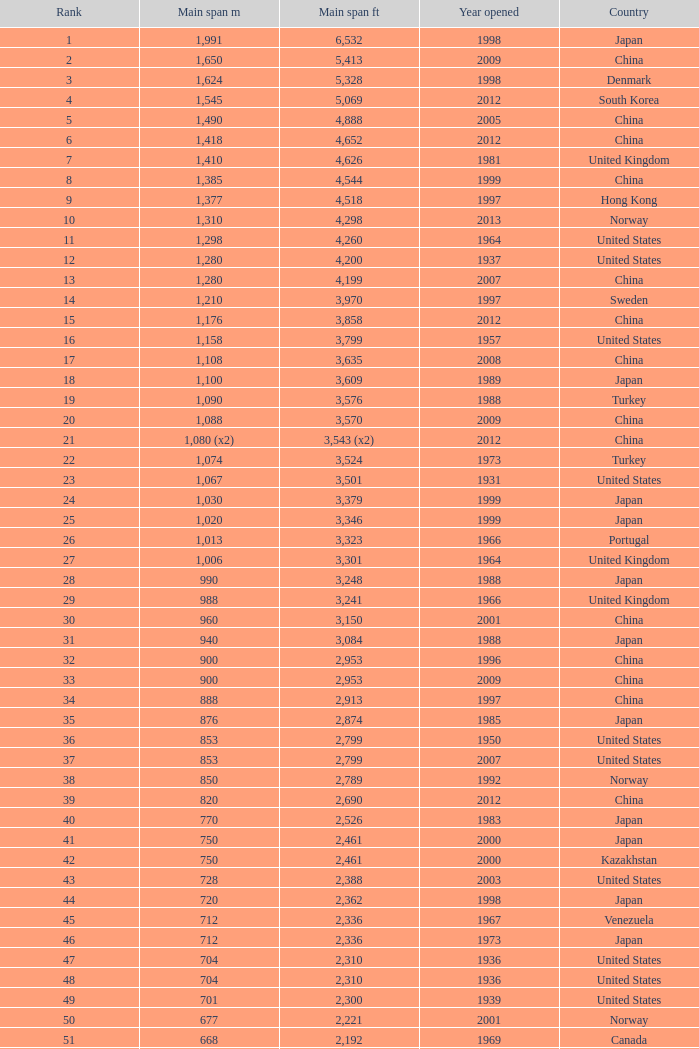What is the highest rank from the year greater than 2010 with 430 main span metres? 94.0. 